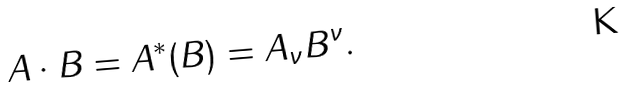<formula> <loc_0><loc_0><loc_500><loc_500>A \cdot B = A ^ { * } ( B ) = A { _ { \nu } } B ^ { \nu } .</formula> 